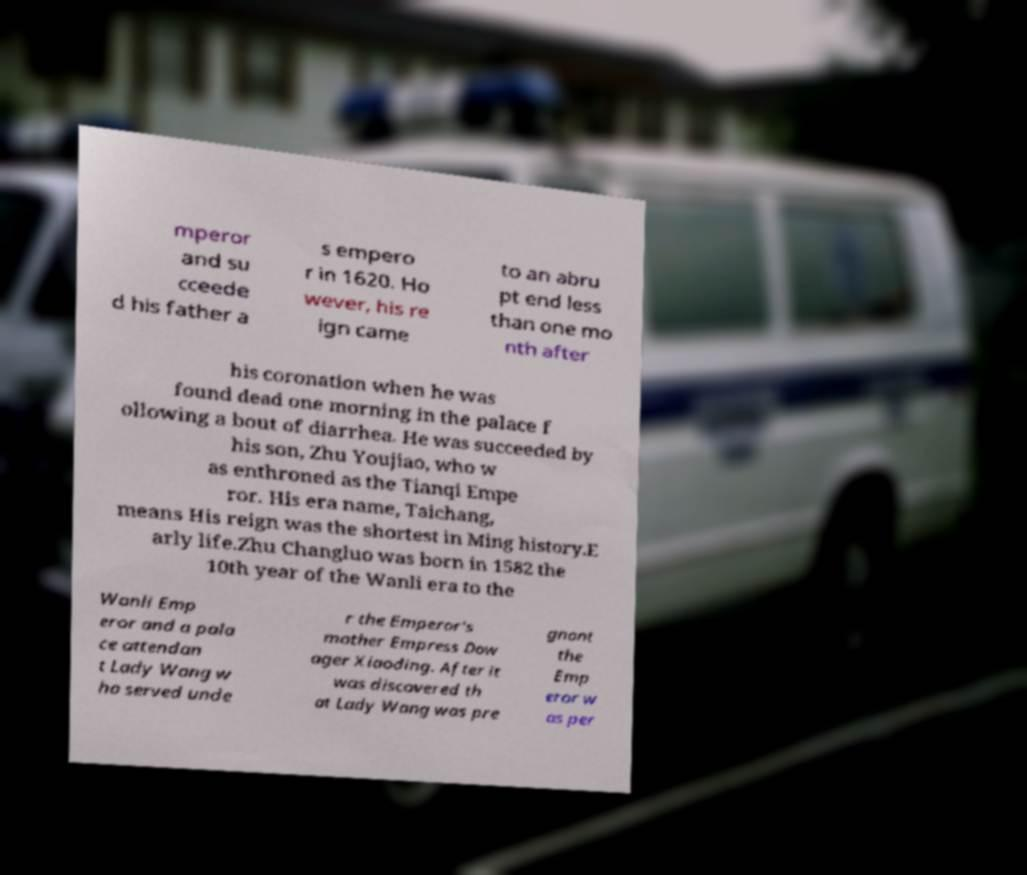Could you extract and type out the text from this image? mperor and su cceede d his father a s empero r in 1620. Ho wever, his re ign came to an abru pt end less than one mo nth after his coronation when he was found dead one morning in the palace f ollowing a bout of diarrhea. He was succeeded by his son, Zhu Youjiao, who w as enthroned as the Tianqi Empe ror. His era name, Taichang, means His reign was the shortest in Ming history.E arly life.Zhu Changluo was born in 1582 the 10th year of the Wanli era to the Wanli Emp eror and a pala ce attendan t Lady Wang w ho served unde r the Emperor's mother Empress Dow ager Xiaoding. After it was discovered th at Lady Wang was pre gnant the Emp eror w as per 